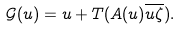Convert formula to latex. <formula><loc_0><loc_0><loc_500><loc_500>\mathcal { G } ( u ) = u + T ( A ( u ) \overline { u \zeta } ) .</formula> 